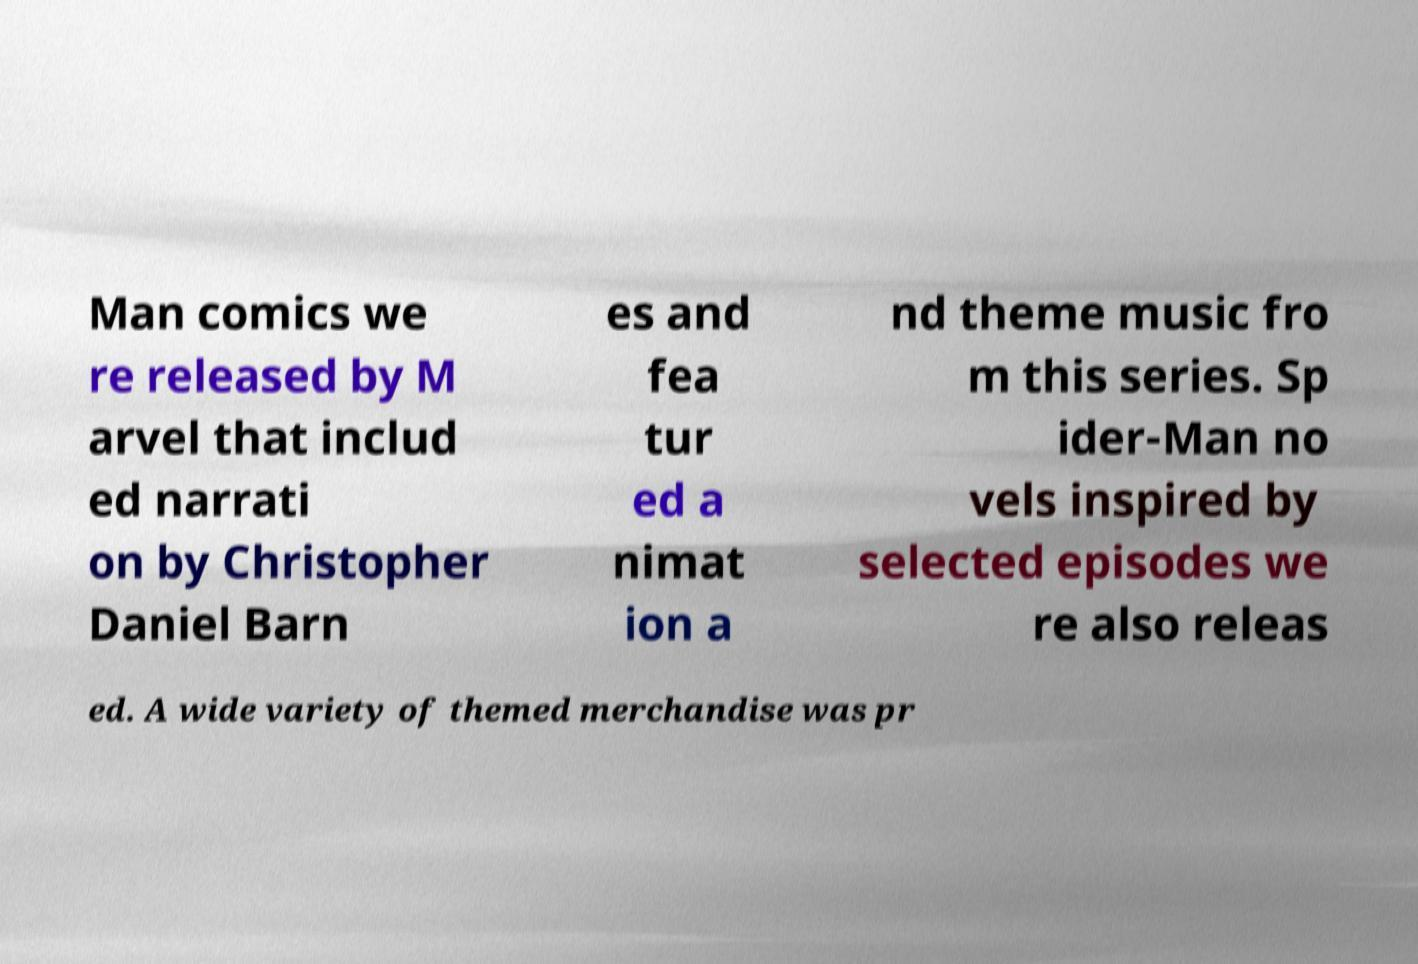What messages or text are displayed in this image? I need them in a readable, typed format. Man comics we re released by M arvel that includ ed narrati on by Christopher Daniel Barn es and fea tur ed a nimat ion a nd theme music fro m this series. Sp ider-Man no vels inspired by selected episodes we re also releas ed. A wide variety of themed merchandise was pr 